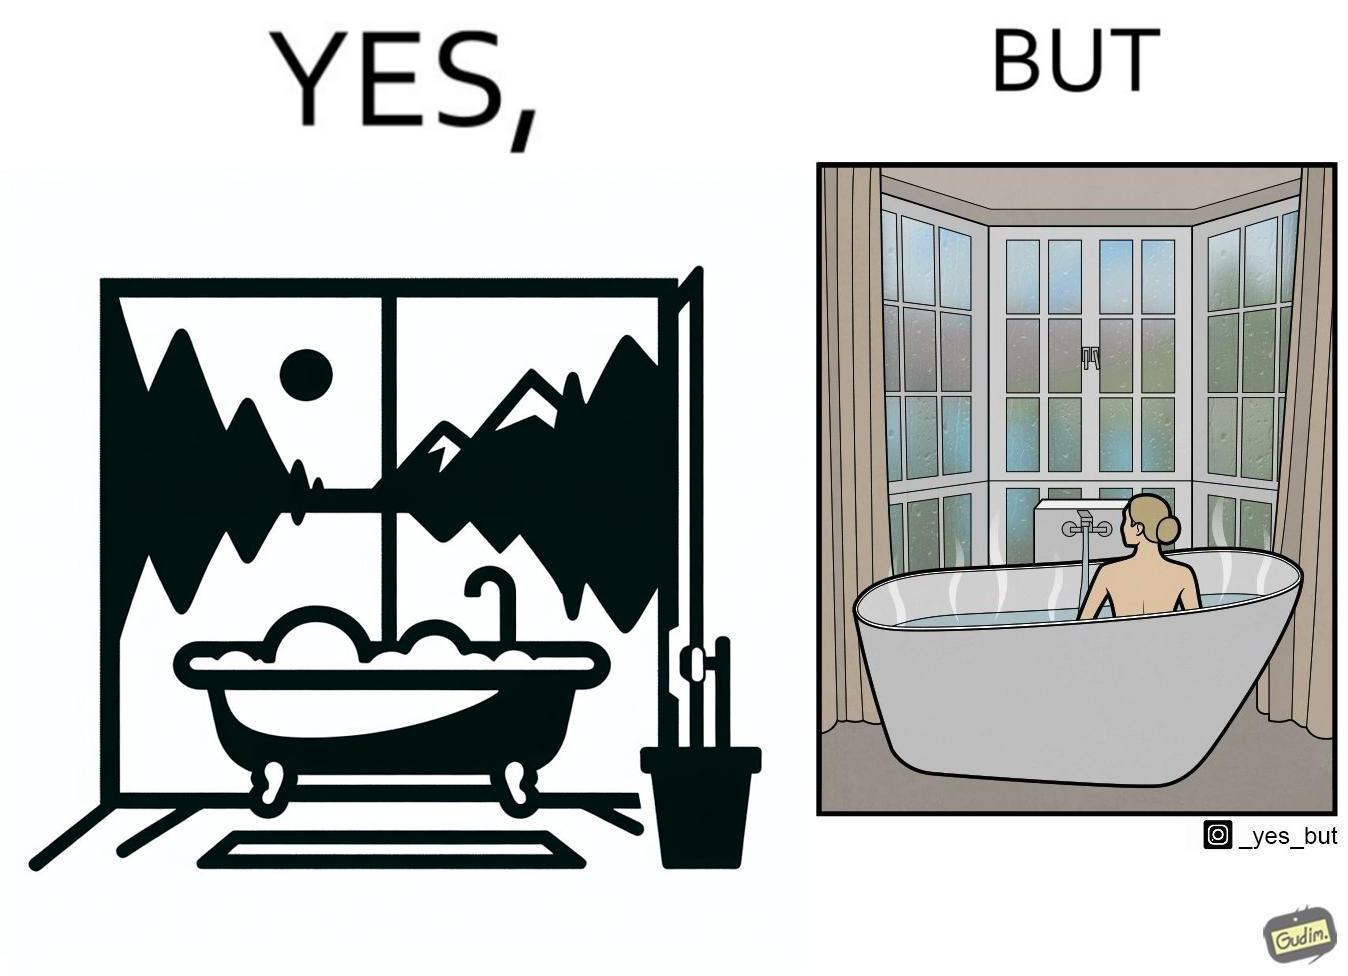Describe what you see in this image. The image is ironical, as a bathtub near a window having a very scenic view, becomes misty when someone is bathing, thus making the scenic view blurry. 